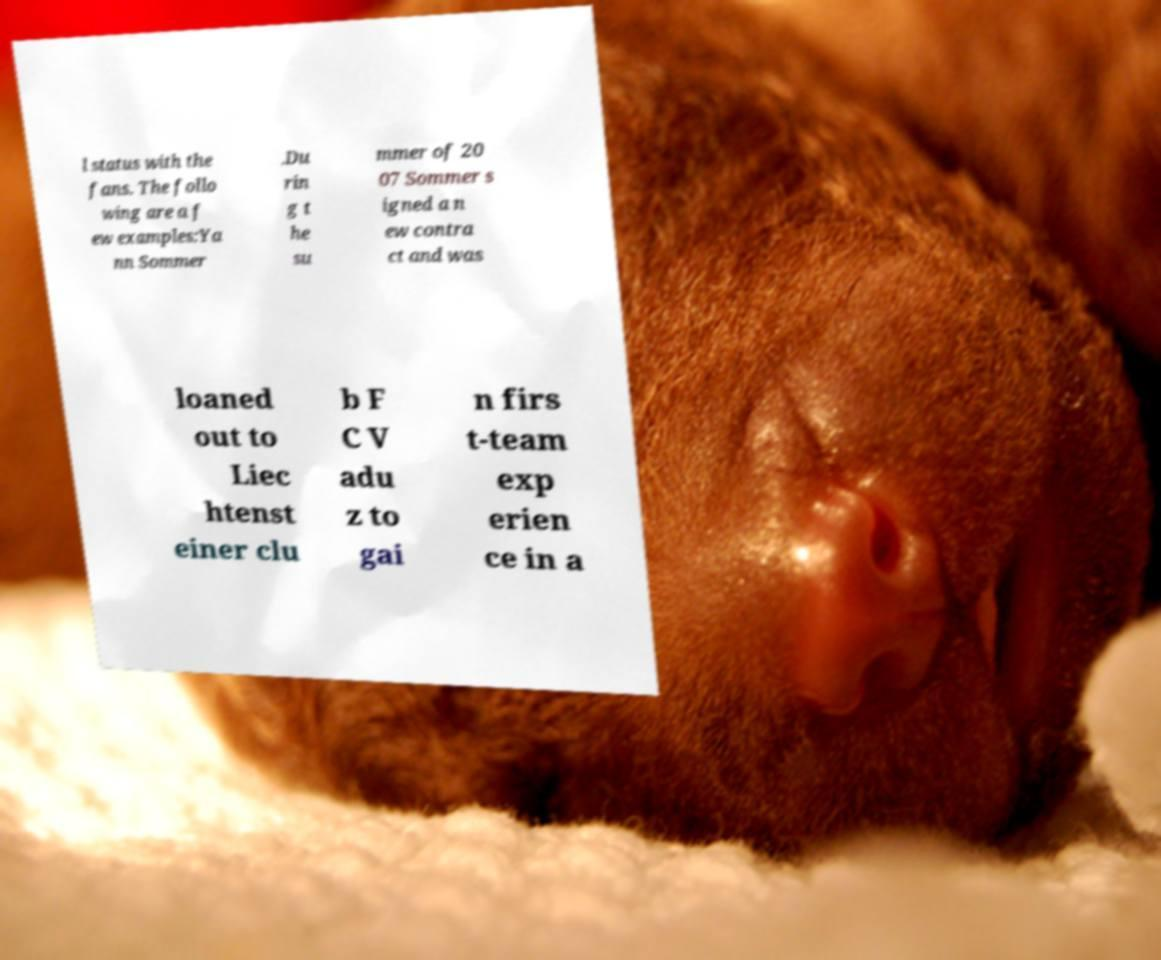Can you accurately transcribe the text from the provided image for me? l status with the fans. The follo wing are a f ew examples:Ya nn Sommer .Du rin g t he su mmer of 20 07 Sommer s igned a n ew contra ct and was loaned out to Liec htenst einer clu b F C V adu z to gai n firs t-team exp erien ce in a 